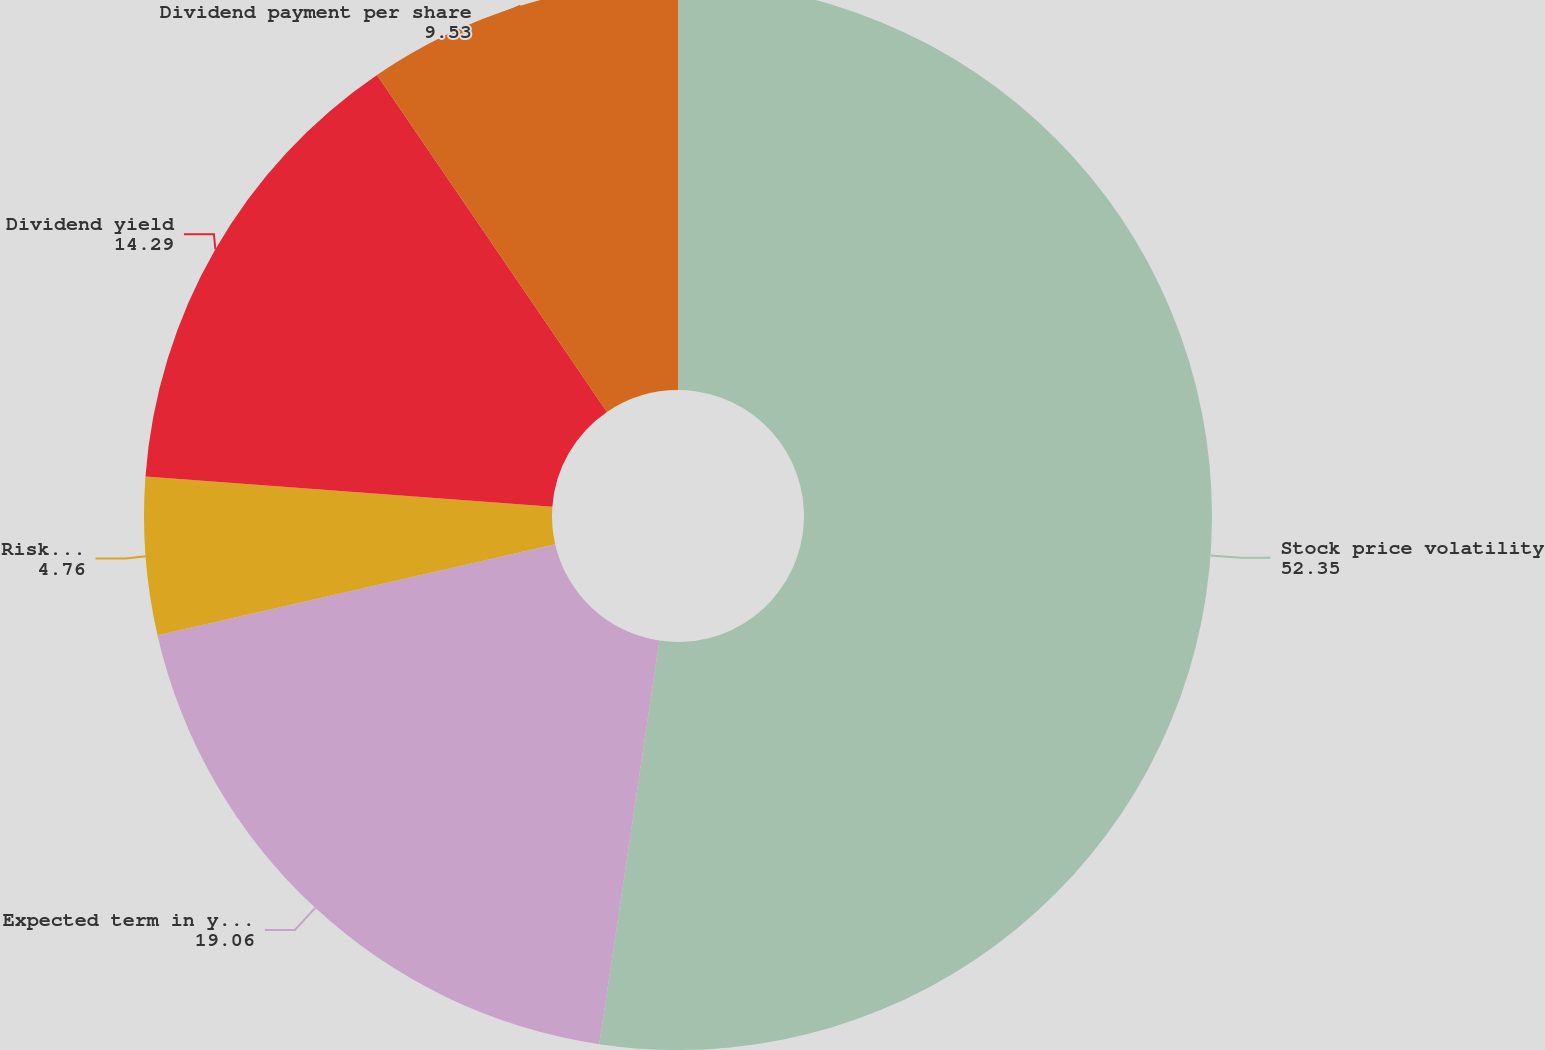<chart> <loc_0><loc_0><loc_500><loc_500><pie_chart><fcel>Stock price volatility<fcel>Expected term in years<fcel>Risk-free interest rate<fcel>Dividend yield<fcel>Dividend payment per share<nl><fcel>52.35%<fcel>19.06%<fcel>4.76%<fcel>14.29%<fcel>9.53%<nl></chart> 